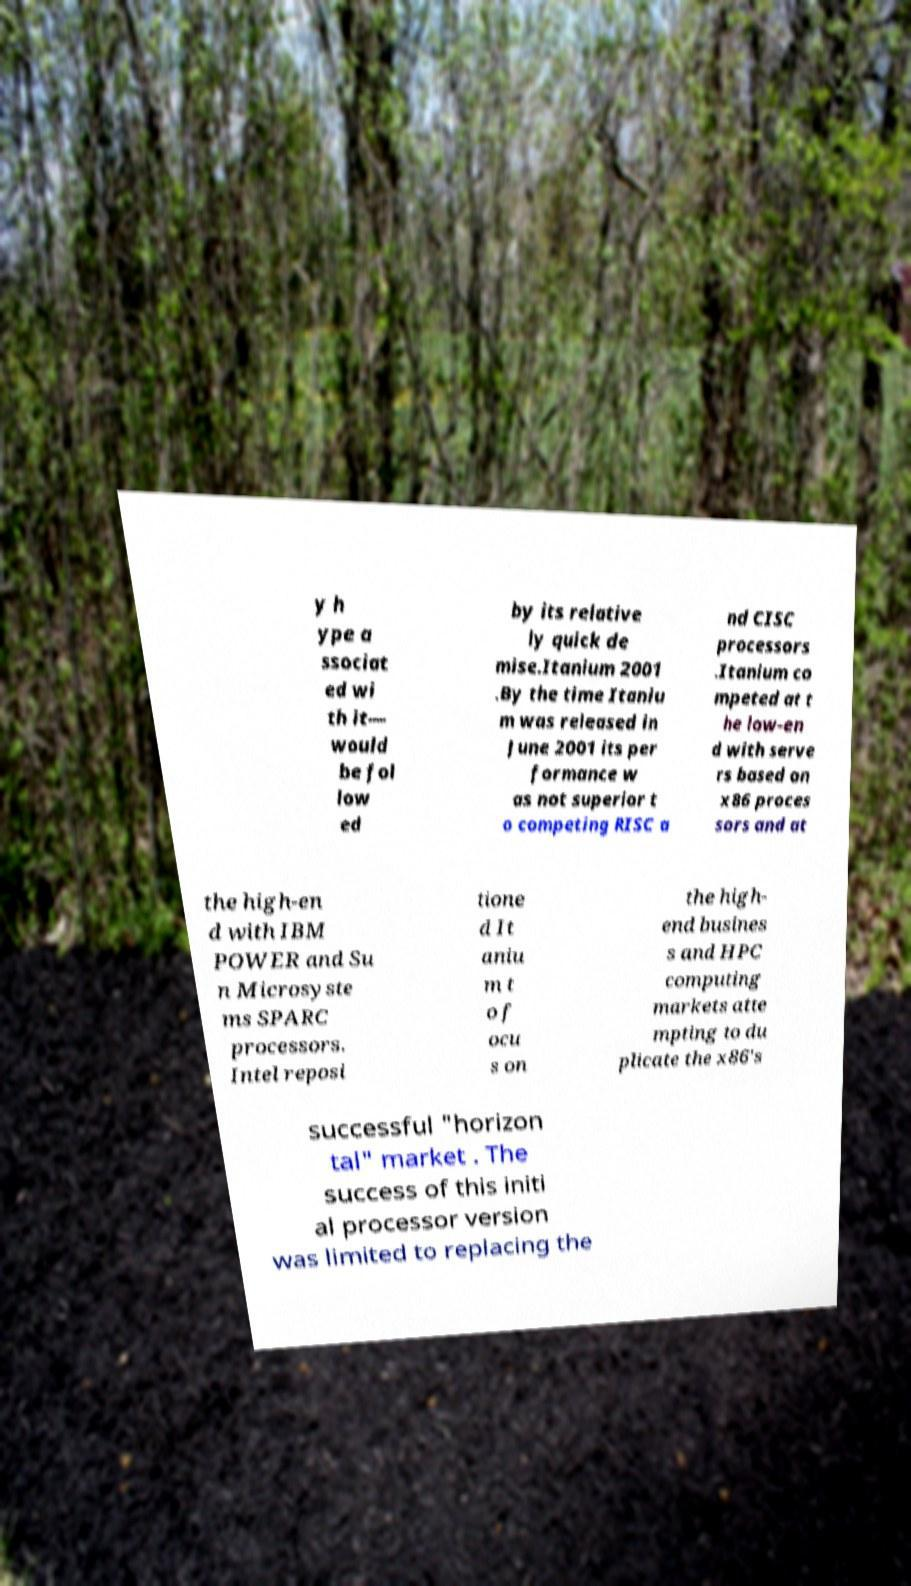Please identify and transcribe the text found in this image. y h ype a ssociat ed wi th it— would be fol low ed by its relative ly quick de mise.Itanium 2001 .By the time Itaniu m was released in June 2001 its per formance w as not superior t o competing RISC a nd CISC processors .Itanium co mpeted at t he low-en d with serve rs based on x86 proces sors and at the high-en d with IBM POWER and Su n Microsyste ms SPARC processors. Intel reposi tione d It aniu m t o f ocu s on the high- end busines s and HPC computing markets atte mpting to du plicate the x86's successful "horizon tal" market . The success of this initi al processor version was limited to replacing the 